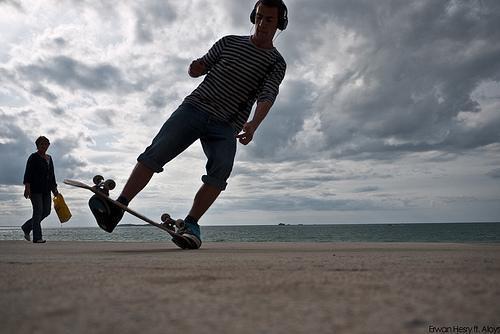How many people are in the photo?
Give a very brief answer. 2. 